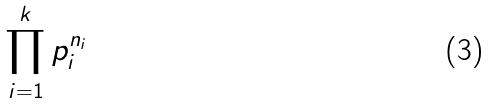Convert formula to latex. <formula><loc_0><loc_0><loc_500><loc_500>\prod _ { i = 1 } ^ { k } p _ { i } ^ { n _ { i } }</formula> 